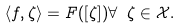Convert formula to latex. <formula><loc_0><loc_0><loc_500><loc_500>\langle f , \zeta \rangle = F ( [ \zeta ] ) \forall \ \zeta \in \mathcal { X } .</formula> 